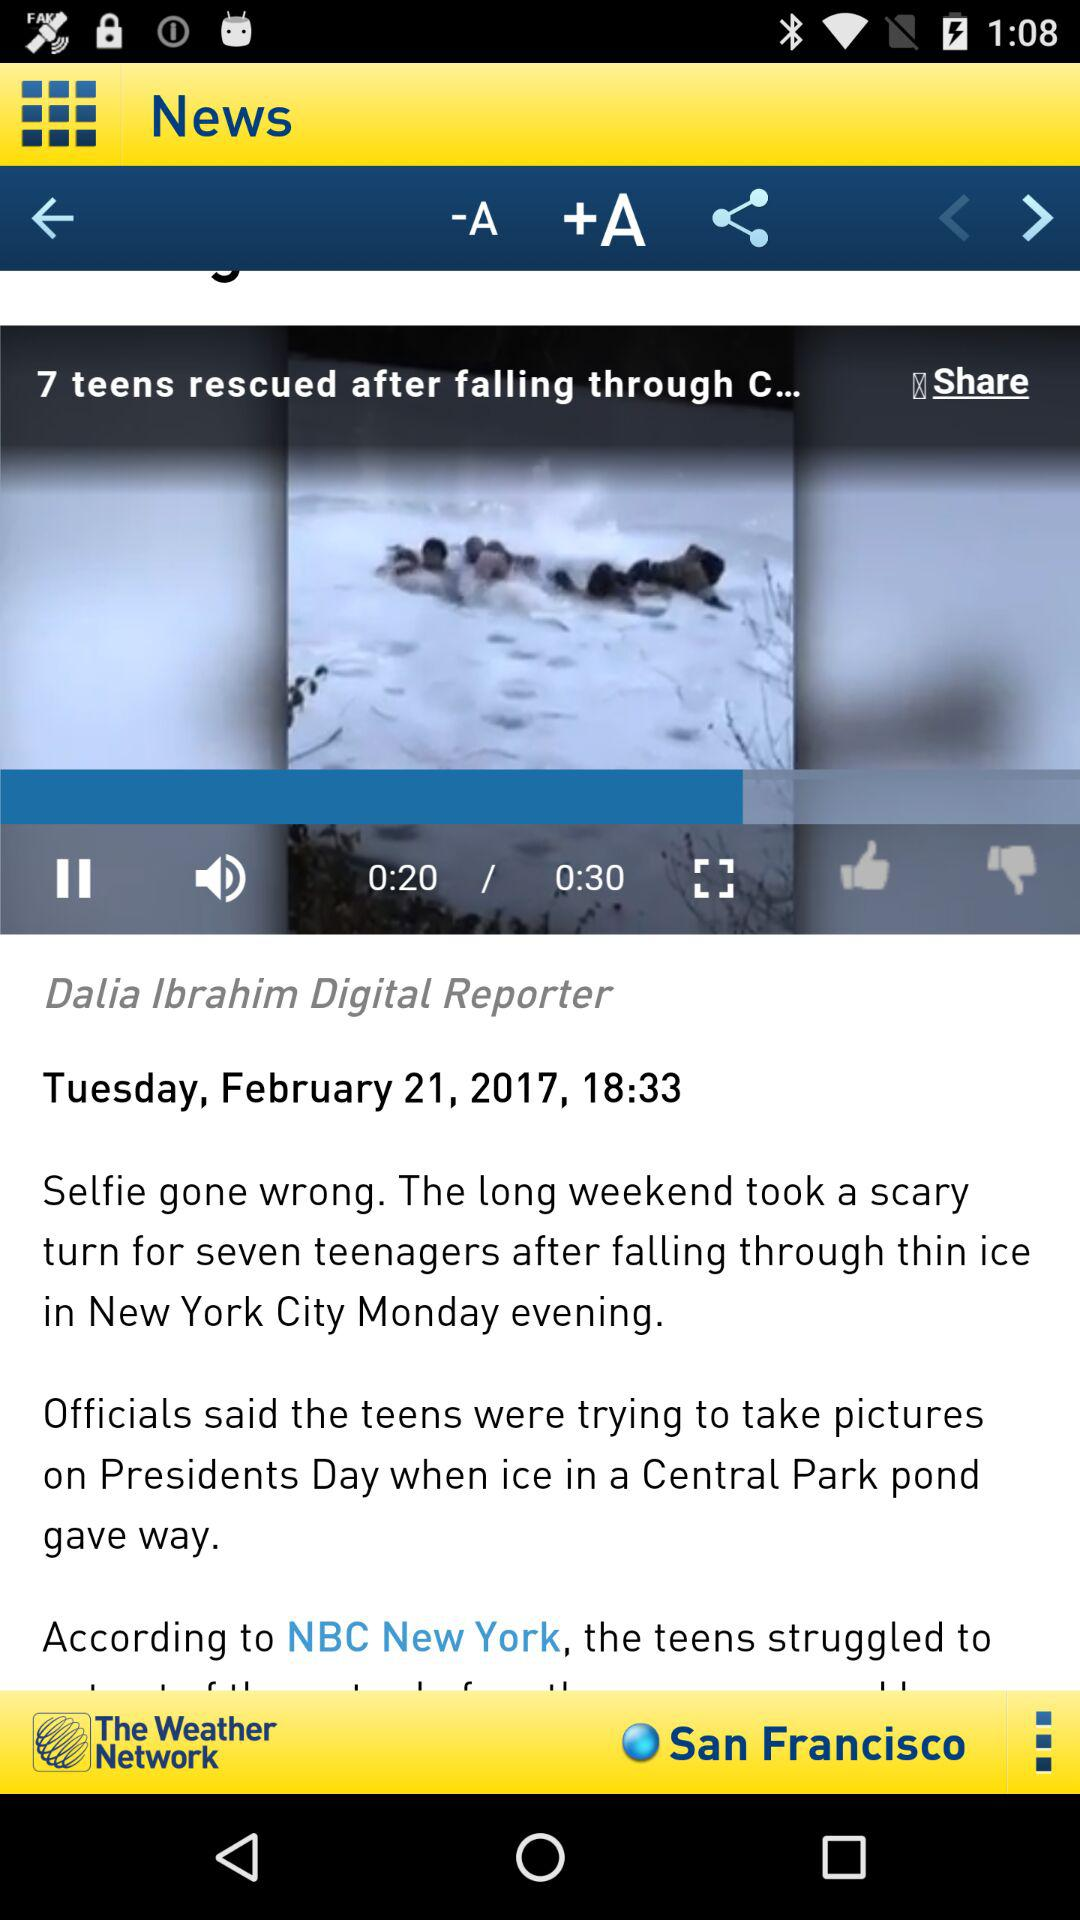How many pages long is the article?
When the provided information is insufficient, respond with <no answer>. <no answer> 